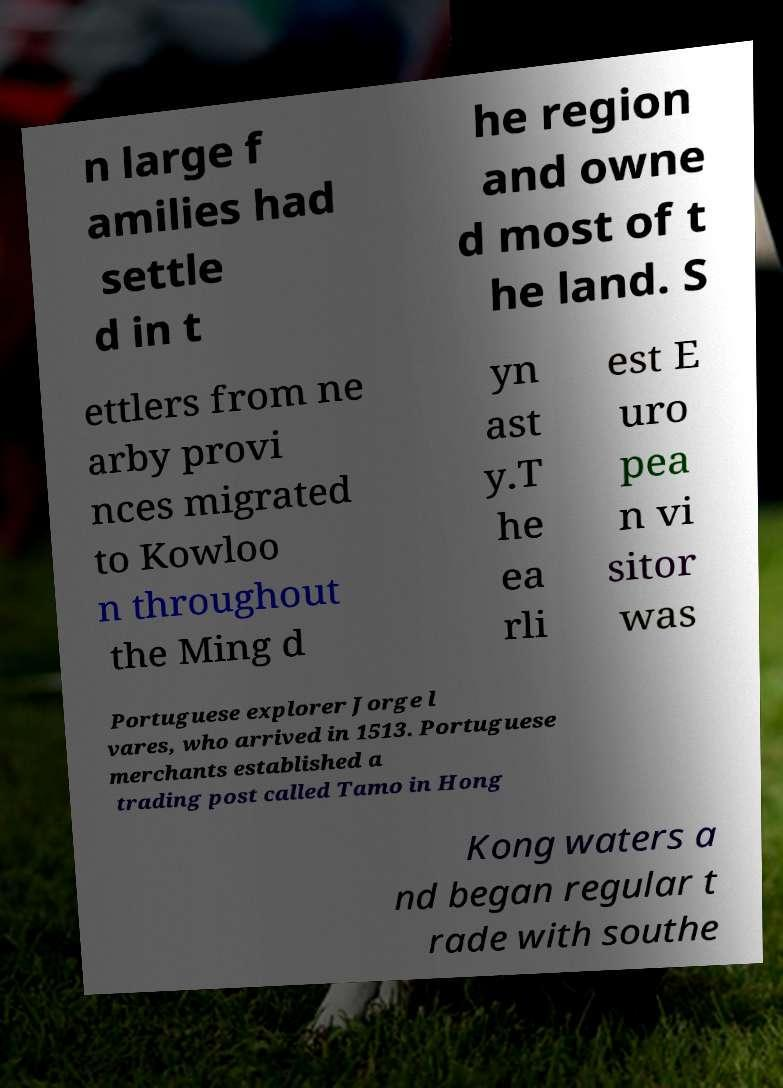Please identify and transcribe the text found in this image. n large f amilies had settle d in t he region and owne d most of t he land. S ettlers from ne arby provi nces migrated to Kowloo n throughout the Ming d yn ast y.T he ea rli est E uro pea n vi sitor was Portuguese explorer Jorge l vares, who arrived in 1513. Portuguese merchants established a trading post called Tamo in Hong Kong waters a nd began regular t rade with southe 